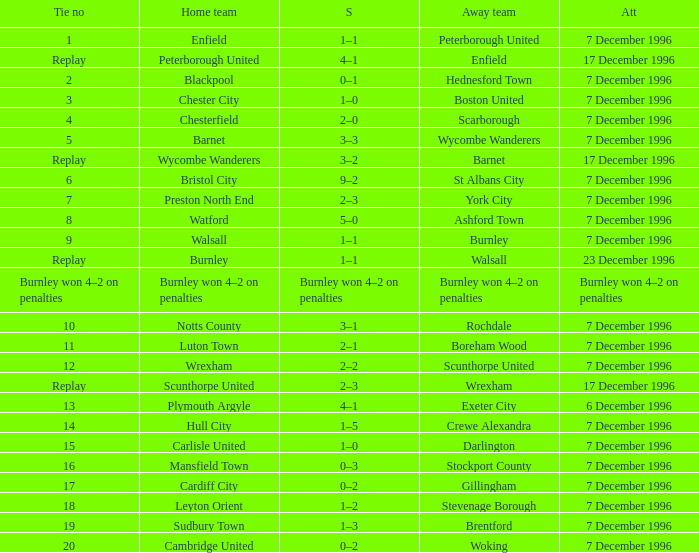Who were the away team in tie number 20? Woking. 